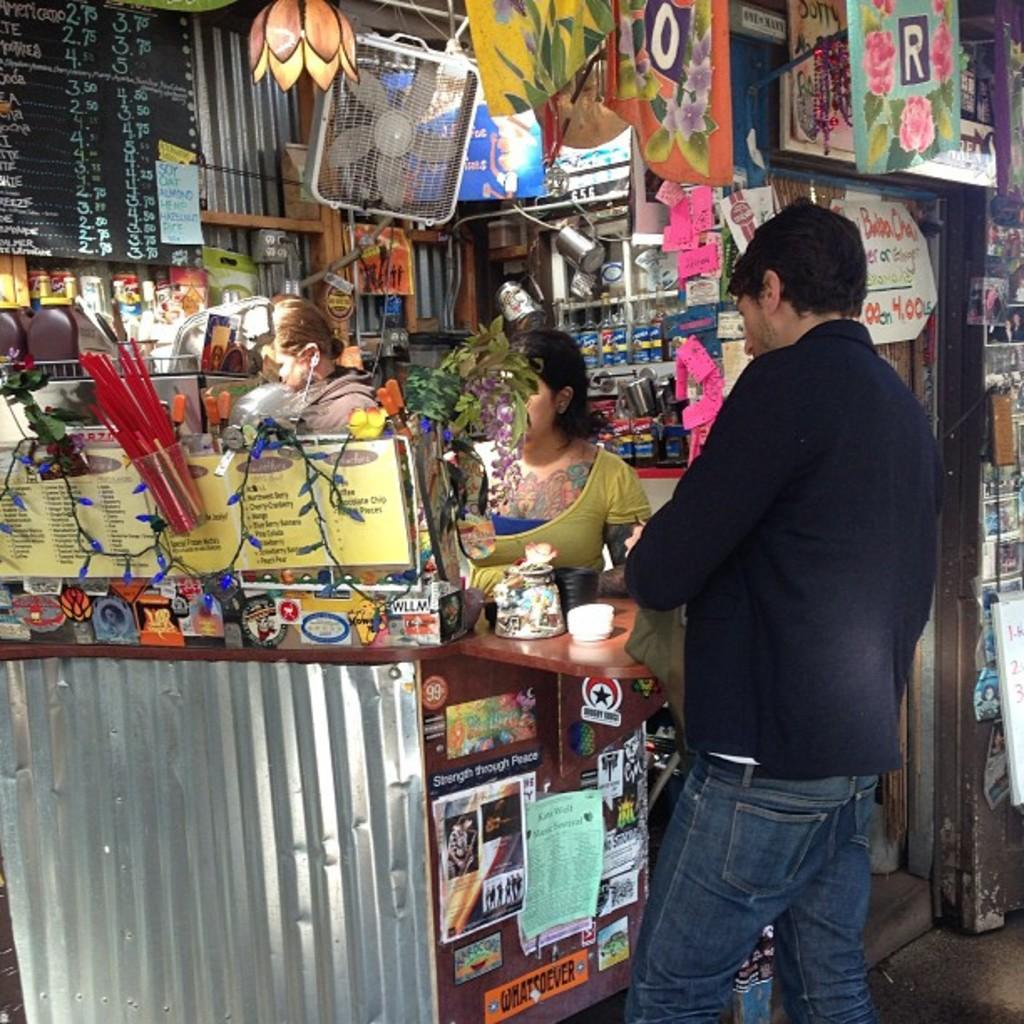Provide a one-sentence caption for the provided image. A man is ordering from a coffee shop that has soy, oat, almond and hemp milk available. 